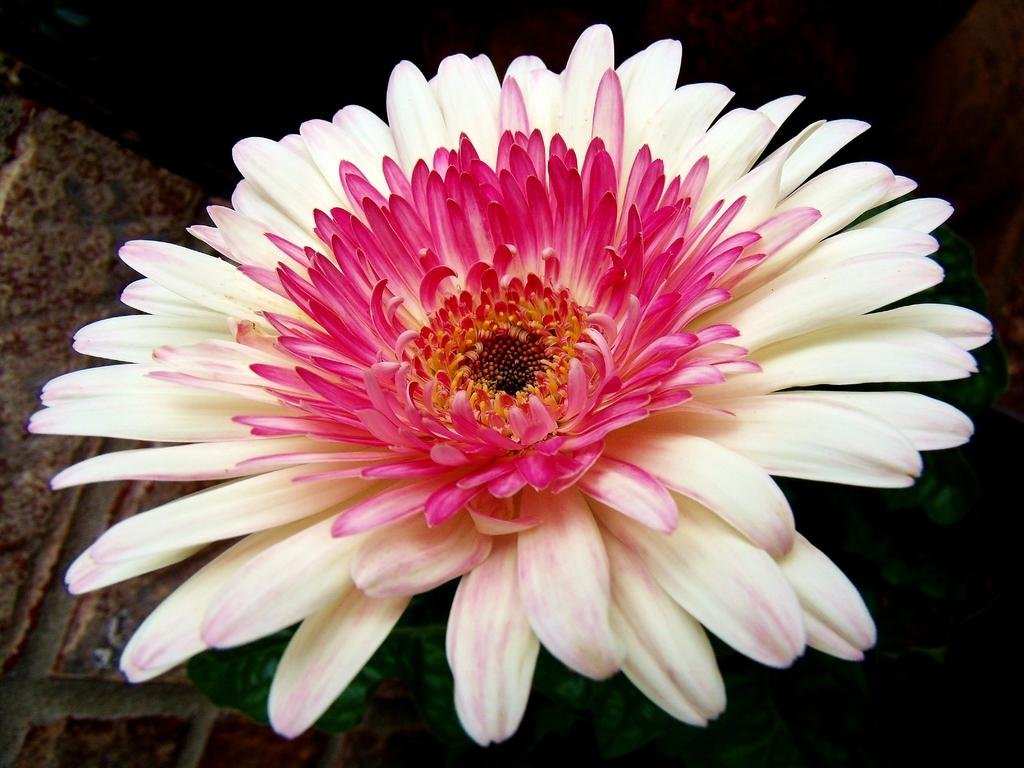What is the main subject of the image? The main subject of the image is a flower. Can you describe the colors of the flower? The flower has white and pink colors. What else is visible on the flower besides the petals? The flower has leaves. What type of reward is the flower holding in the image? There is no reward present in the image; it is a flower with white and pink colors and leaves. 